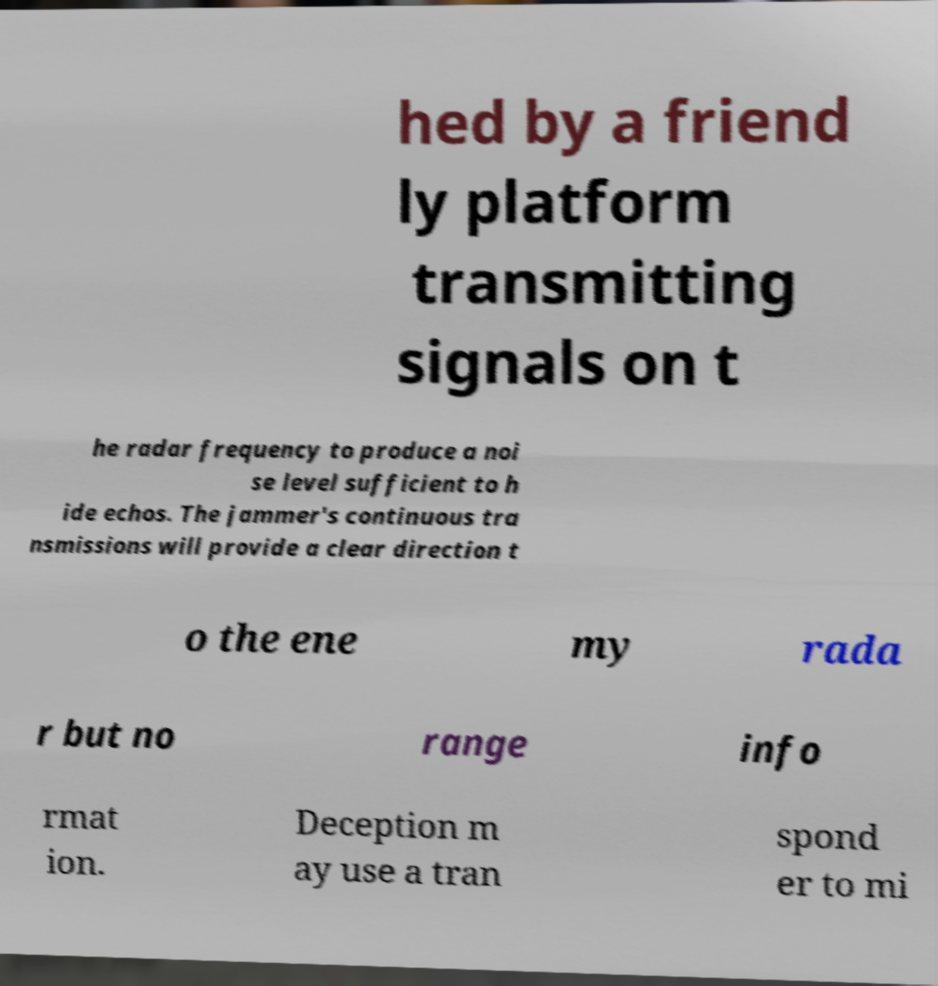For documentation purposes, I need the text within this image transcribed. Could you provide that? hed by a friend ly platform transmitting signals on t he radar frequency to produce a noi se level sufficient to h ide echos. The jammer's continuous tra nsmissions will provide a clear direction t o the ene my rada r but no range info rmat ion. Deception m ay use a tran spond er to mi 